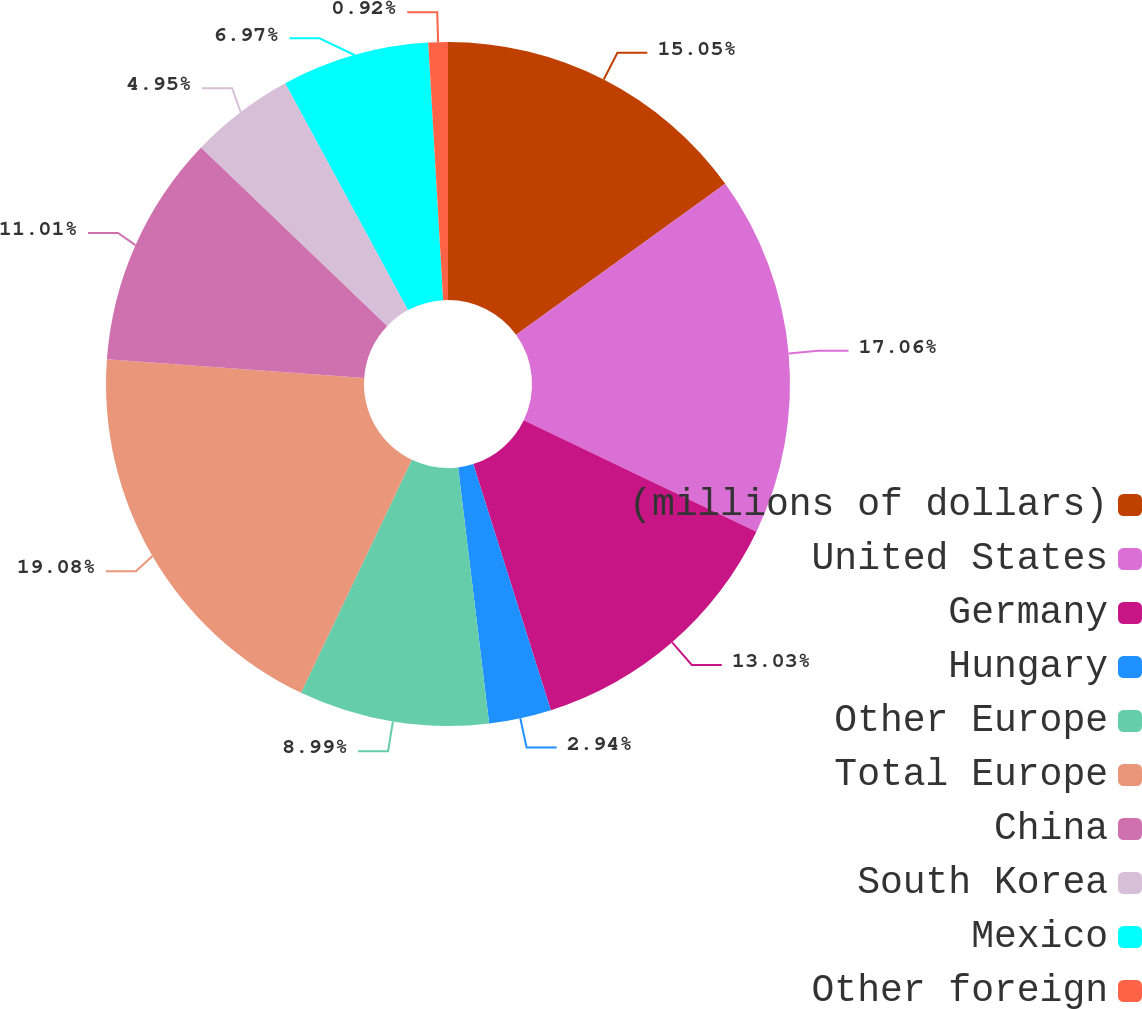<chart> <loc_0><loc_0><loc_500><loc_500><pie_chart><fcel>(millions of dollars)<fcel>United States<fcel>Germany<fcel>Hungary<fcel>Other Europe<fcel>Total Europe<fcel>China<fcel>South Korea<fcel>Mexico<fcel>Other foreign<nl><fcel>15.05%<fcel>17.06%<fcel>13.03%<fcel>2.94%<fcel>8.99%<fcel>19.08%<fcel>11.01%<fcel>4.95%<fcel>6.97%<fcel>0.92%<nl></chart> 